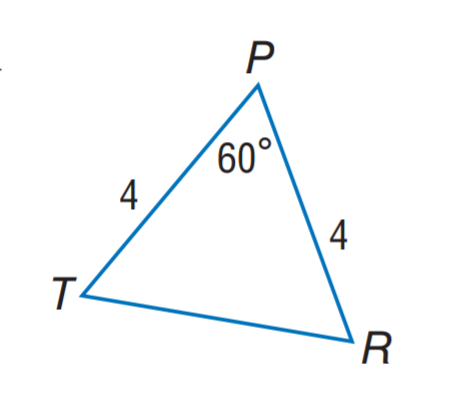Answer the mathemtical geometry problem and directly provide the correct option letter.
Question: Find T R.
Choices: A: 2 B: 4 C: 5 D: 8 B 